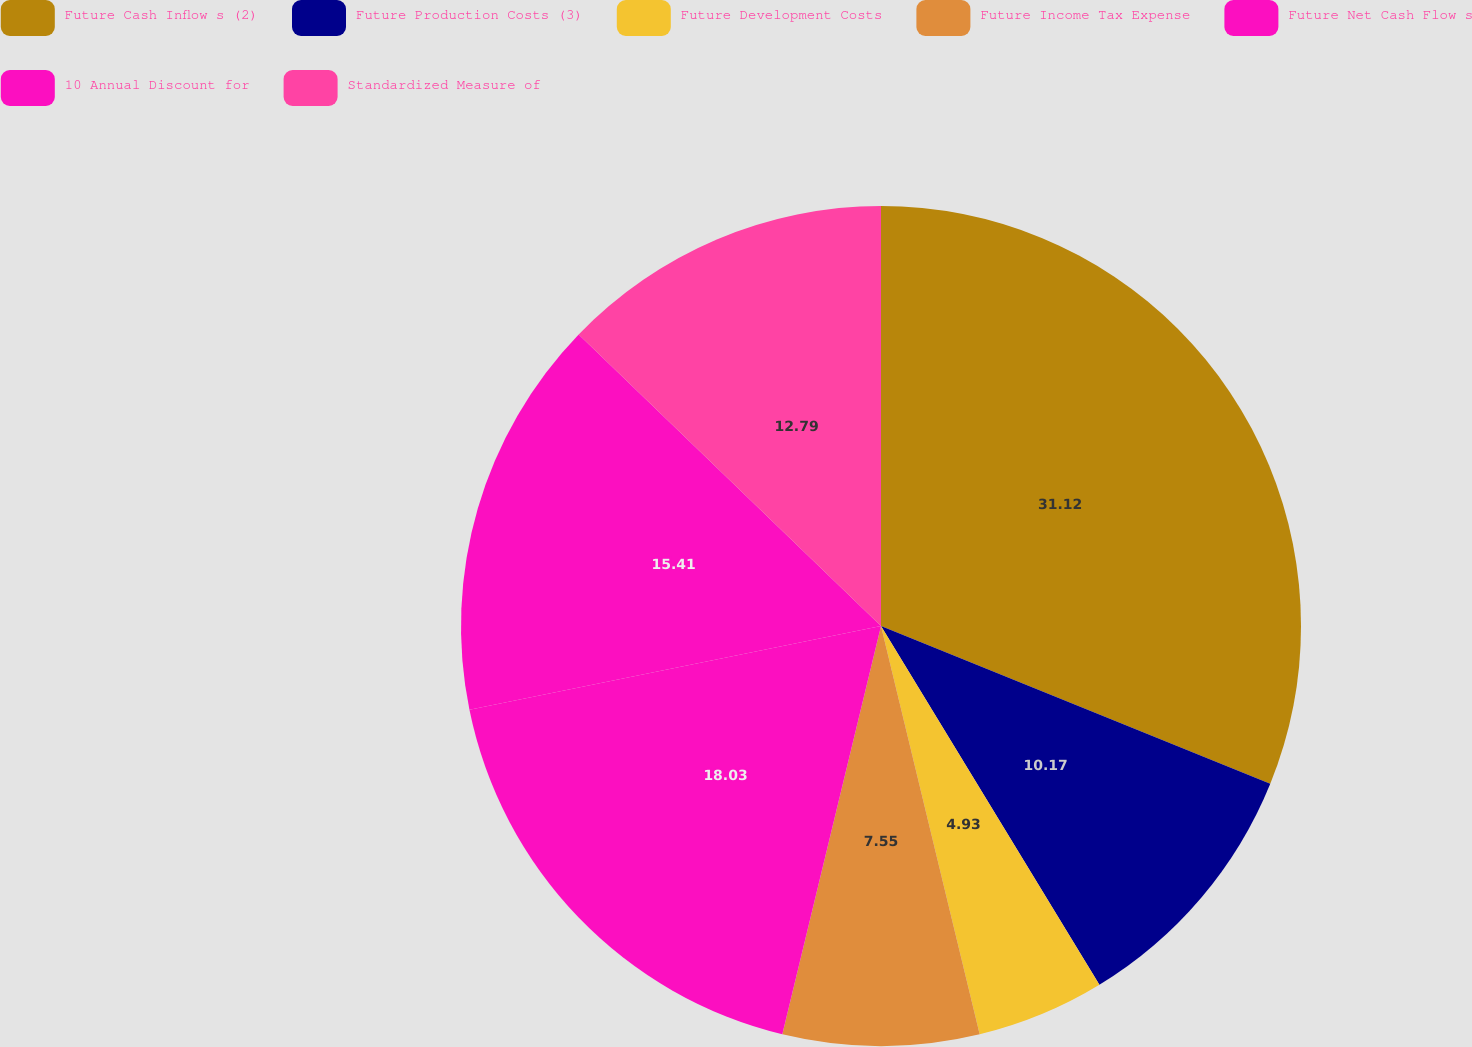Convert chart to OTSL. <chart><loc_0><loc_0><loc_500><loc_500><pie_chart><fcel>Future Cash Inflow s (2)<fcel>Future Production Costs (3)<fcel>Future Development Costs<fcel>Future Income Tax Expense<fcel>Future Net Cash Flow s<fcel>10 Annual Discount for<fcel>Standardized Measure of<nl><fcel>31.13%<fcel>10.17%<fcel>4.93%<fcel>7.55%<fcel>18.03%<fcel>15.41%<fcel>12.79%<nl></chart> 